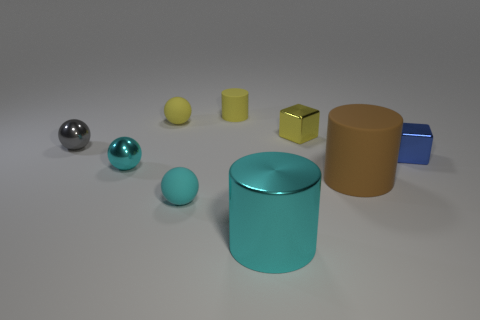There is a thing in front of the cyan rubber thing; what color is it?
Provide a short and direct response. Cyan. There is a shiny block behind the blue cube; are there any rubber cylinders that are to the left of it?
Offer a terse response. Yes. Do the small blue shiny object and the big object that is to the left of the tiny yellow cube have the same shape?
Provide a short and direct response. No. There is a cylinder that is behind the cyan matte object and in front of the tiny yellow sphere; what size is it?
Keep it short and to the point. Large. Are there any yellow objects made of the same material as the big brown thing?
Provide a succinct answer. Yes. There is a metallic thing that is the same color as the metal cylinder; what size is it?
Ensure brevity in your answer.  Small. The block right of the metallic object that is behind the gray metal ball is made of what material?
Your answer should be compact. Metal. What number of cubes are the same color as the small matte cylinder?
Keep it short and to the point. 1. There is a cyan ball that is the same material as the large cyan cylinder; what size is it?
Provide a short and direct response. Small. There is a large thing that is to the right of the big cyan shiny object; what shape is it?
Your answer should be compact. Cylinder. 